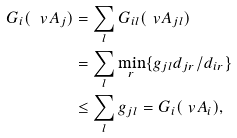Convert formula to latex. <formula><loc_0><loc_0><loc_500><loc_500>G _ { i } ( \ v A _ { j } ) & = \sum _ { l } G _ { i l } ( \ v A _ { j l } ) \\ & = \sum _ { l } \min _ { r } \{ g _ { j l } d _ { j r } / d _ { i r } \} \\ & \leq \sum _ { l } g _ { j l } = G _ { i } ( \ v A _ { i } ) ,</formula> 